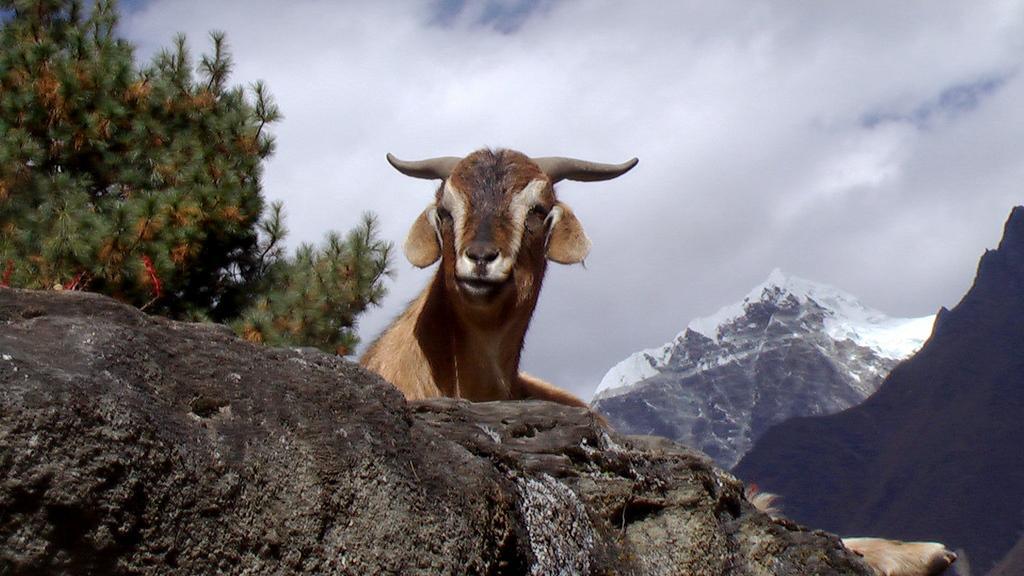Can you describe this image briefly? This is an outside view. At the bottom there is a rock. Behind the rock, I can see an animal. On the left side there is a tree. In the background, I can see the mountains. At the top, I can see the sky and clouds. 